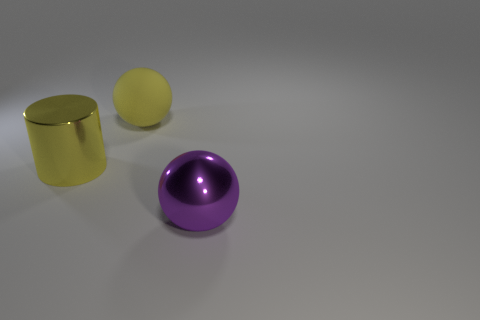Add 3 big metal cylinders. How many objects exist? 6 Subtract all cylinders. How many objects are left? 2 Add 1 yellow rubber spheres. How many yellow rubber spheres are left? 2 Add 3 big purple cylinders. How many big purple cylinders exist? 3 Subtract 0 red cylinders. How many objects are left? 3 Subtract all big brown rubber objects. Subtract all big yellow shiny things. How many objects are left? 2 